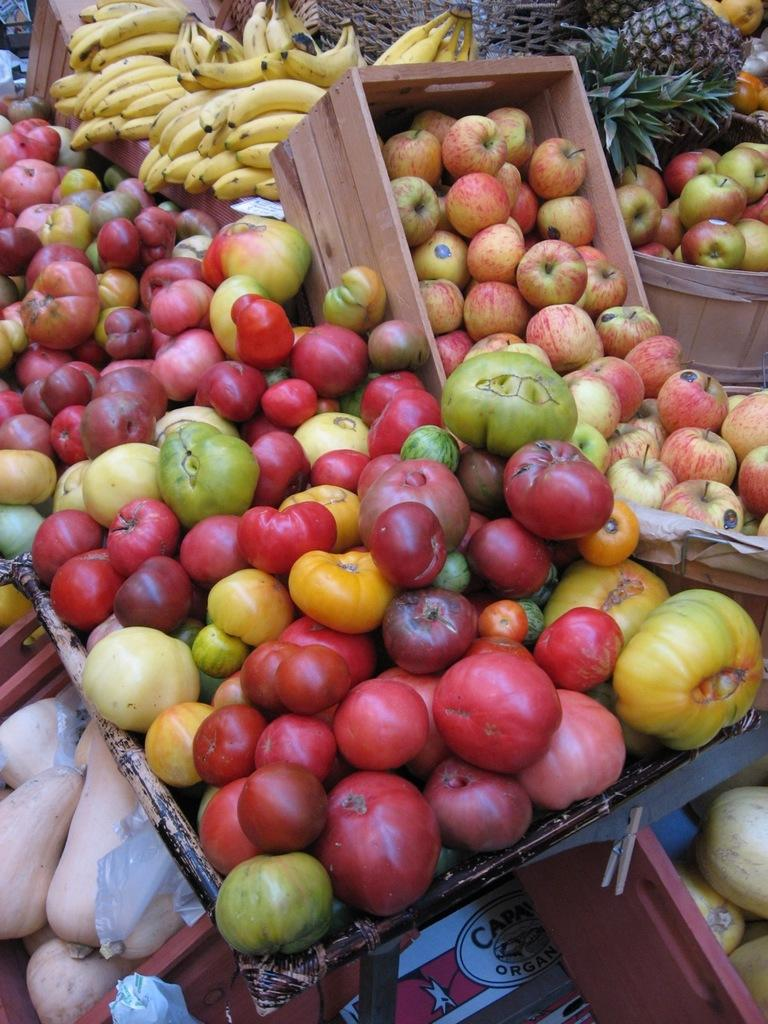What types of fruits can be seen in the image? There are different types of fruits in the image, including apples, bananas, and pineapples. Can you identify any other fruits in the image? Yes, there are other fruits in the image, but they are not specified. How are the fruits arranged or displayed in the image? The fruits are in a basket in the image. What time of day is the protest taking place in the image? There is no protest present in the image; it features a basket of fruits. What type of operation is being performed on the fruits in the image? There is no operation being performed on the fruits in the image; they are simply displayed in a basket. 